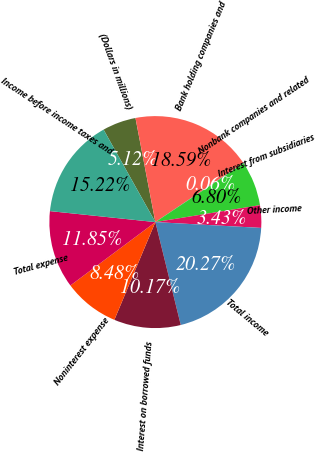Convert chart. <chart><loc_0><loc_0><loc_500><loc_500><pie_chart><fcel>(Dollars in millions)<fcel>Bank holding companies and<fcel>Nonbank companies and related<fcel>Interest from subsidiaries<fcel>Other income<fcel>Total income<fcel>Interest on borrowed funds<fcel>Noninterest expense<fcel>Total expense<fcel>Income before income taxes and<nl><fcel>5.12%<fcel>18.59%<fcel>0.06%<fcel>6.8%<fcel>3.43%<fcel>20.27%<fcel>10.17%<fcel>8.48%<fcel>11.85%<fcel>15.22%<nl></chart> 